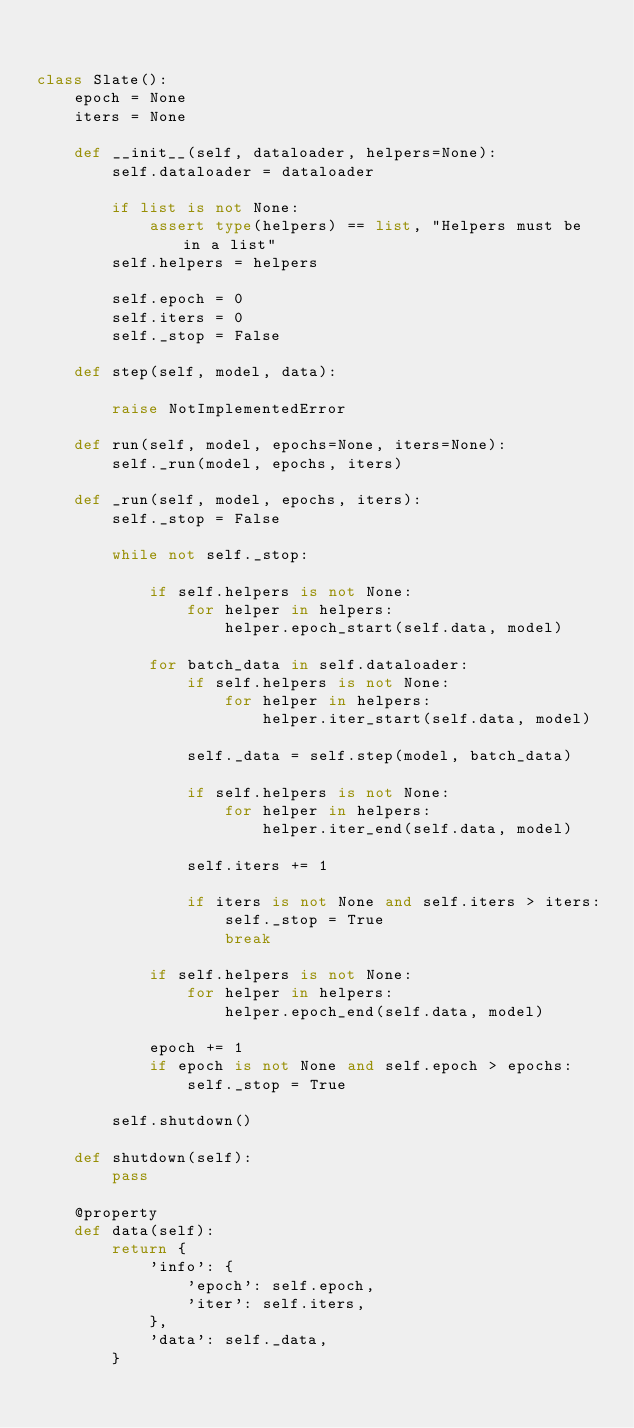Convert code to text. <code><loc_0><loc_0><loc_500><loc_500><_Python_>

class Slate():
    epoch = None
    iters = None

    def __init__(self, dataloader, helpers=None):
        self.dataloader = dataloader

        if list is not None:
            assert type(helpers) == list, "Helpers must be in a list"
        self.helpers = helpers

        self.epoch = 0
        self.iters = 0
        self._stop = False

    def step(self, model, data):

        raise NotImplementedError

    def run(self, model, epochs=None, iters=None):
        self._run(model, epochs, iters)

    def _run(self, model, epochs, iters):
        self._stop = False

        while not self._stop:

            if self.helpers is not None:
                for helper in helpers:
                    helper.epoch_start(self.data, model)

            for batch_data in self.dataloader:
                if self.helpers is not None:
                    for helper in helpers:
                        helper.iter_start(self.data, model)

                self._data = self.step(model, batch_data)

                if self.helpers is not None:
                    for helper in helpers:
                        helper.iter_end(self.data, model)

                self.iters += 1

                if iters is not None and self.iters > iters:
                    self._stop = True
                    break

            if self.helpers is not None:
                for helper in helpers:
                    helper.epoch_end(self.data, model)

            epoch += 1
            if epoch is not None and self.epoch > epochs:
                self._stop = True

        self.shutdown()

    def shutdown(self):
        pass

    @property
    def data(self):
        return {
            'info': {
                'epoch': self.epoch,
                'iter': self.iters,
            },
            'data': self._data,
        }
</code> 